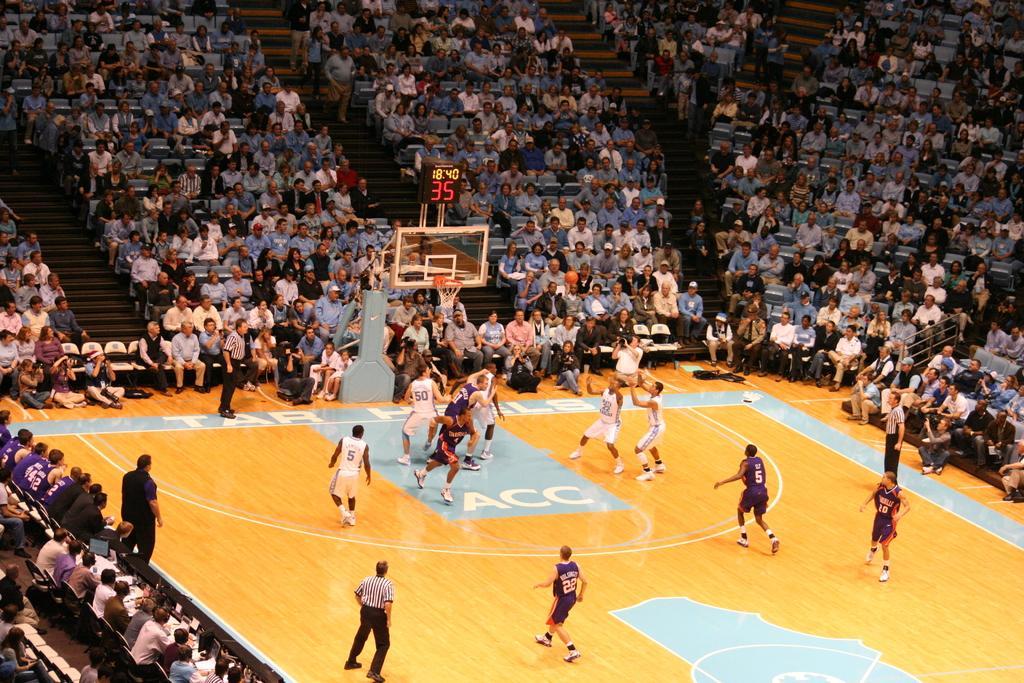Describe this image in one or two sentences. In the image in the center we can see one ball,basket ball court and few people were standing. In the background we can see staircase,banners,chairs,group of peoples were sitting and few peoples were wearing caps. 